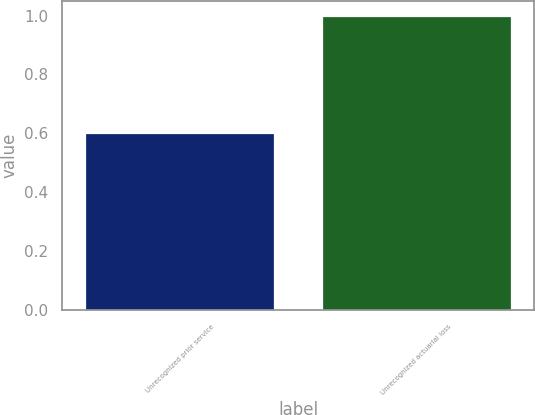<chart> <loc_0><loc_0><loc_500><loc_500><bar_chart><fcel>Unrecognized prior service<fcel>Unrecognized actuarial loss<nl><fcel>0.6<fcel>1<nl></chart> 